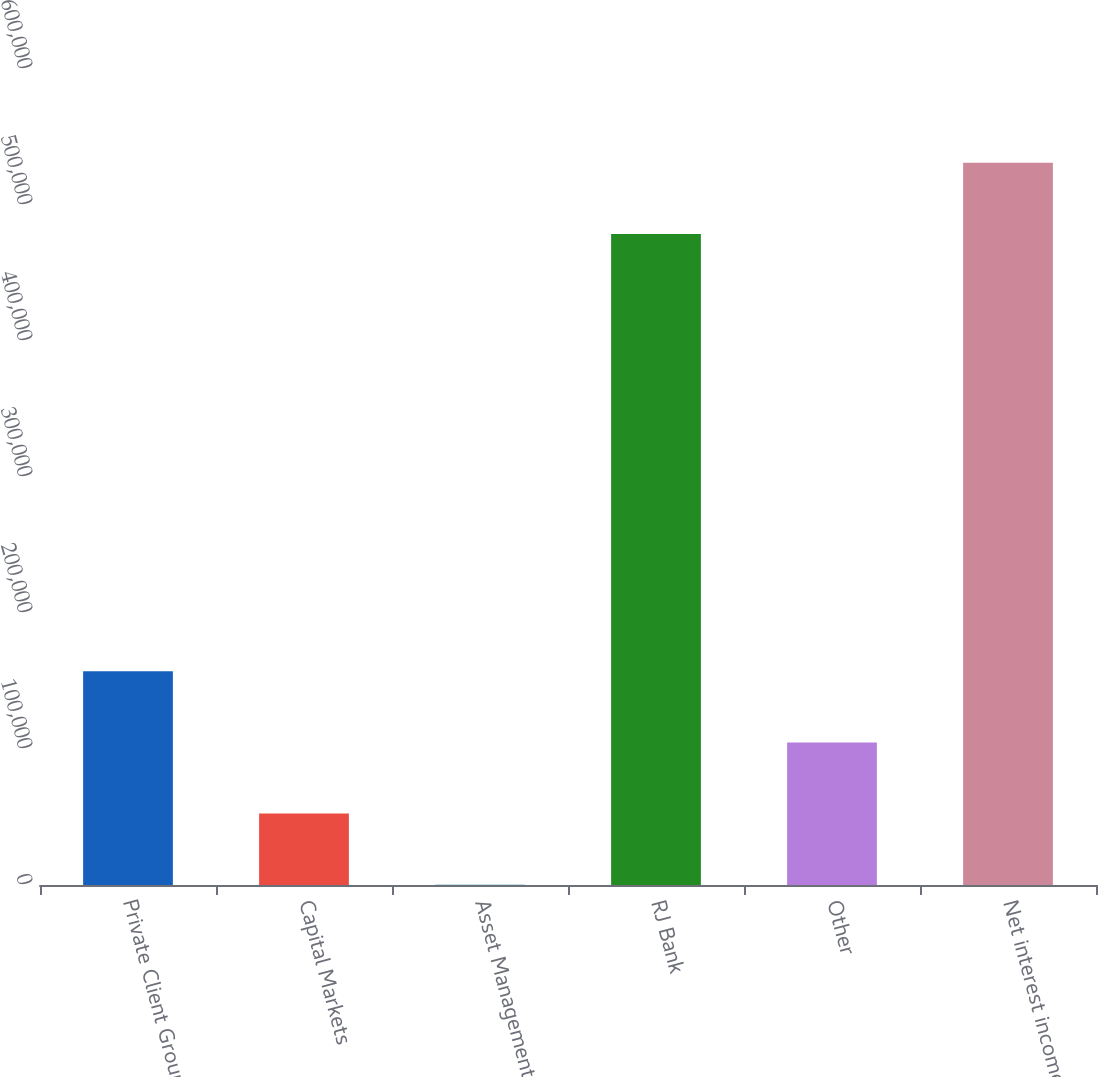Convert chart to OTSL. <chart><loc_0><loc_0><loc_500><loc_500><bar_chart><fcel>Private Client Group<fcel>Capital Markets<fcel>Asset Management<fcel>RJ Bank<fcel>Other<fcel>Net interest income<nl><fcel>157102<fcel>52489.5<fcel>183<fcel>478690<fcel>104796<fcel>530996<nl></chart> 